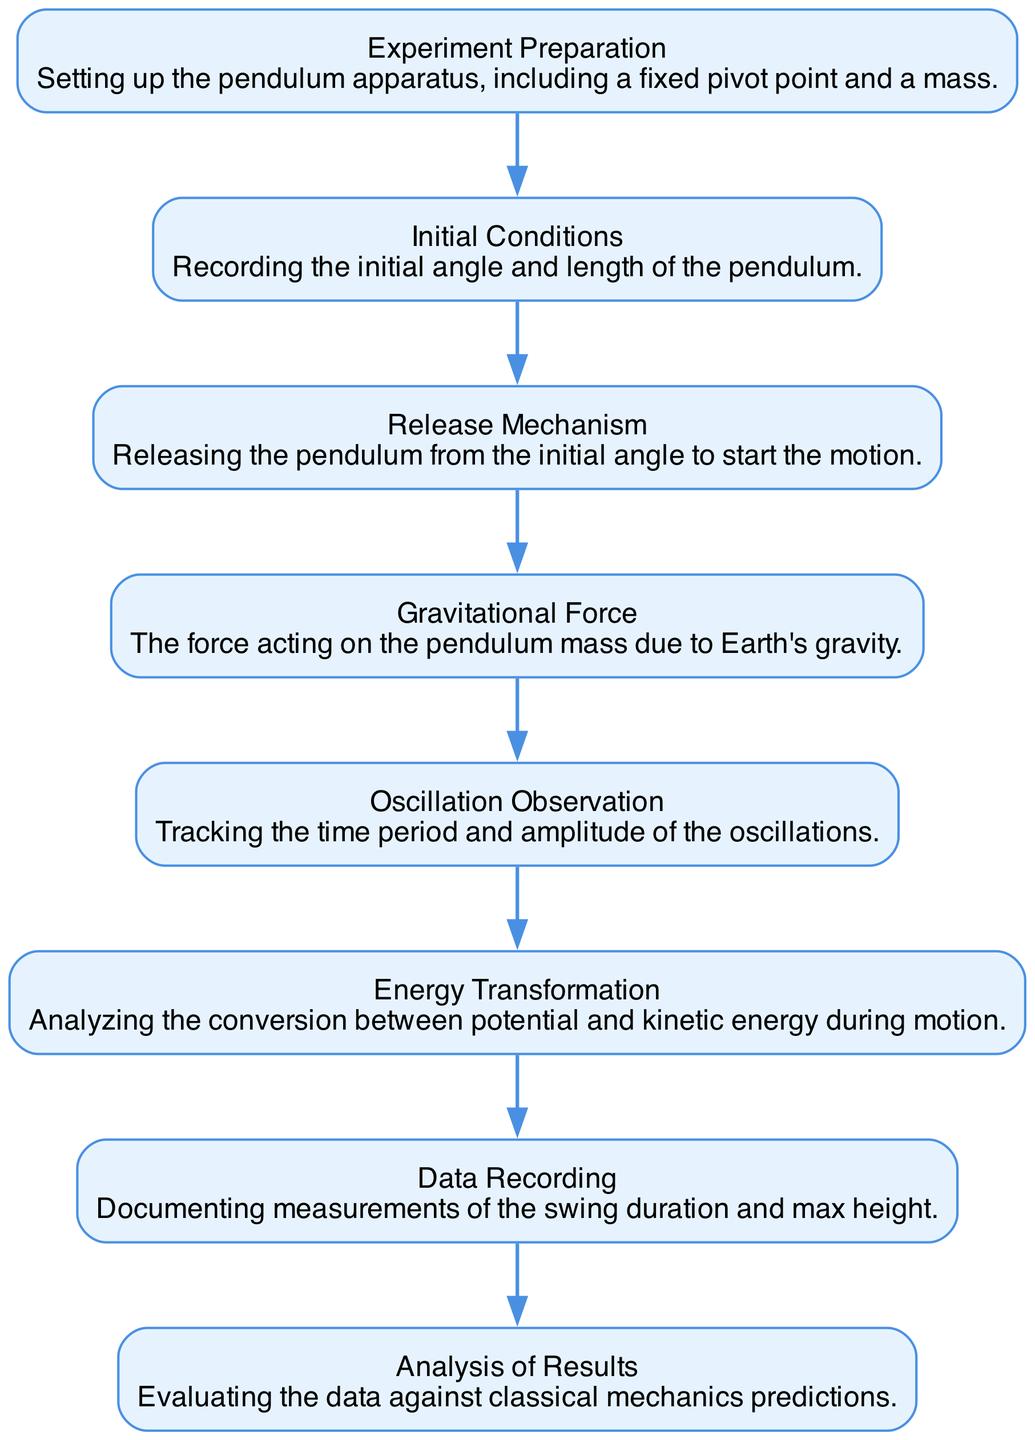What is the first step in the pendulum experiment? The first step is "Experiment Preparation," which involves setting up the pendulum apparatus.
Answer: Experiment Preparation How many nodes are present in the sequence diagram? There are 8 nodes in total representing different stages of the pendulum experiment.
Answer: 8 What follows "Data Recording" in the sequence diagram? "Analysis of Results" follows "Data Recording" as the next step in the process.
Answer: Analysis of Results What type of energy transformation is analyzed in this experiment? The experiment analyzes the conversion between potential and kinetic energy during pendulum motion.
Answer: Potential and kinetic energy How does gravitational force interact in the pendulum experiment? The "Gravitational Force" acts on the pendulum mass, influencing its motion and oscillation.
Answer: Acts on the pendulum mass Which step involves tracking oscillation parameters? The step focused on tracking oscillation parameters is "Oscillation Observation."
Answer: Oscillation Observation What is documented during the "Data Recording" step? The "Data Recording" step involves documenting measurements of swing duration and maximum height.
Answer: Swing duration and maximum height What energy transformations occur during the motion of the pendulum? Energy transformation involves the conversion between potential energy when elevated and kinetic energy during motion.
Answer: Conversion between potential and kinetic energy Which node describes the release of the pendulum? The node that describes the release of the pendulum is "Release Mechanism."
Answer: Release Mechanism 